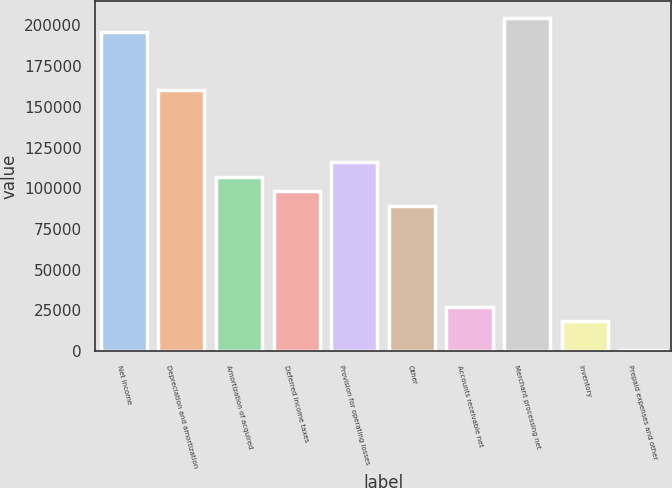<chart> <loc_0><loc_0><loc_500><loc_500><bar_chart><fcel>Net income<fcel>Depreciation and amortization<fcel>Amortization of acquired<fcel>Deferred income taxes<fcel>Provision for operating losses<fcel>Other<fcel>Accounts receivable net<fcel>Merchant processing net<fcel>Inventory<fcel>Prepaid expenses and other<nl><fcel>195865<fcel>160359<fcel>107101<fcel>98224.4<fcel>115977<fcel>89348<fcel>27213.2<fcel>204741<fcel>18336.8<fcel>584<nl></chart> 